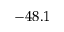Convert formula to latex. <formula><loc_0><loc_0><loc_500><loc_500>- 4 8 . 1</formula> 